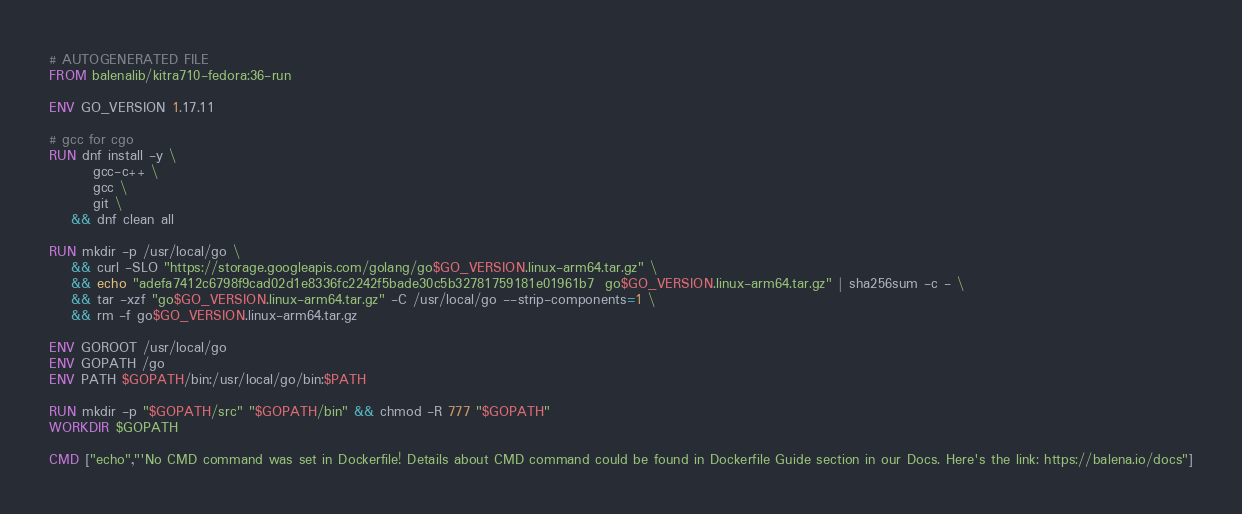Convert code to text. <code><loc_0><loc_0><loc_500><loc_500><_Dockerfile_># AUTOGENERATED FILE
FROM balenalib/kitra710-fedora:36-run

ENV GO_VERSION 1.17.11

# gcc for cgo
RUN dnf install -y \
		gcc-c++ \
		gcc \
		git \
	&& dnf clean all

RUN mkdir -p /usr/local/go \
	&& curl -SLO "https://storage.googleapis.com/golang/go$GO_VERSION.linux-arm64.tar.gz" \
	&& echo "adefa7412c6798f9cad02d1e8336fc2242f5bade30c5b32781759181e01961b7  go$GO_VERSION.linux-arm64.tar.gz" | sha256sum -c - \
	&& tar -xzf "go$GO_VERSION.linux-arm64.tar.gz" -C /usr/local/go --strip-components=1 \
	&& rm -f go$GO_VERSION.linux-arm64.tar.gz

ENV GOROOT /usr/local/go
ENV GOPATH /go
ENV PATH $GOPATH/bin:/usr/local/go/bin:$PATH

RUN mkdir -p "$GOPATH/src" "$GOPATH/bin" && chmod -R 777 "$GOPATH"
WORKDIR $GOPATH

CMD ["echo","'No CMD command was set in Dockerfile! Details about CMD command could be found in Dockerfile Guide section in our Docs. Here's the link: https://balena.io/docs"]
</code> 